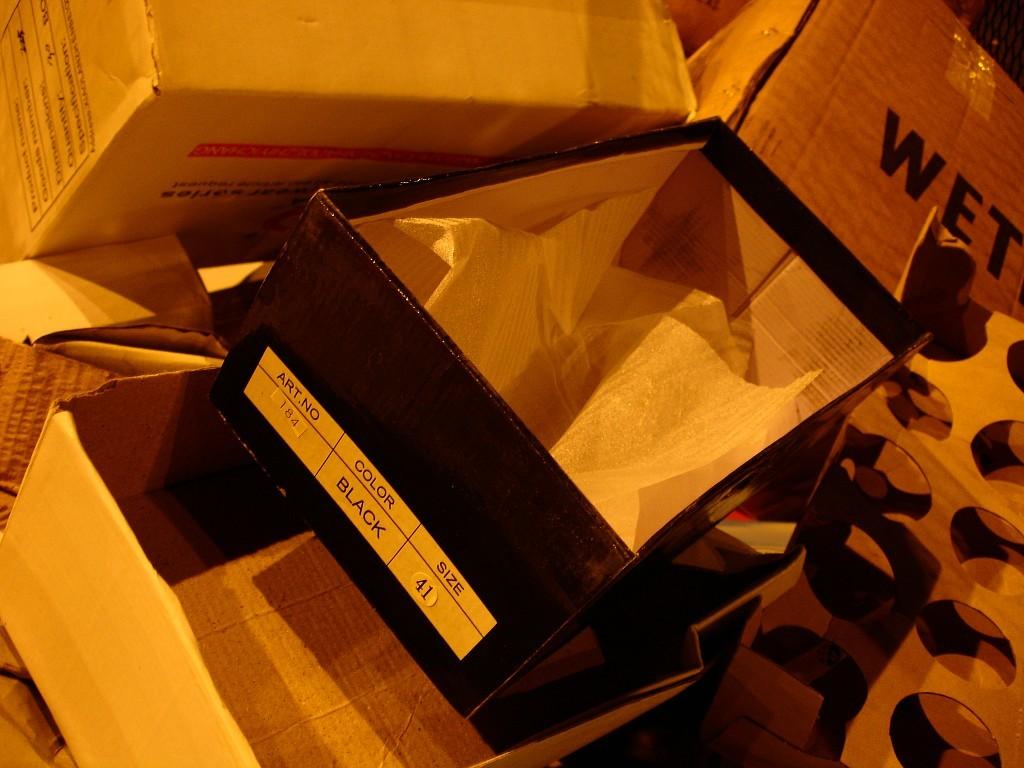What color are the shoes?
Offer a terse response. Black. What was in that box?
Your answer should be compact. Shoes. 